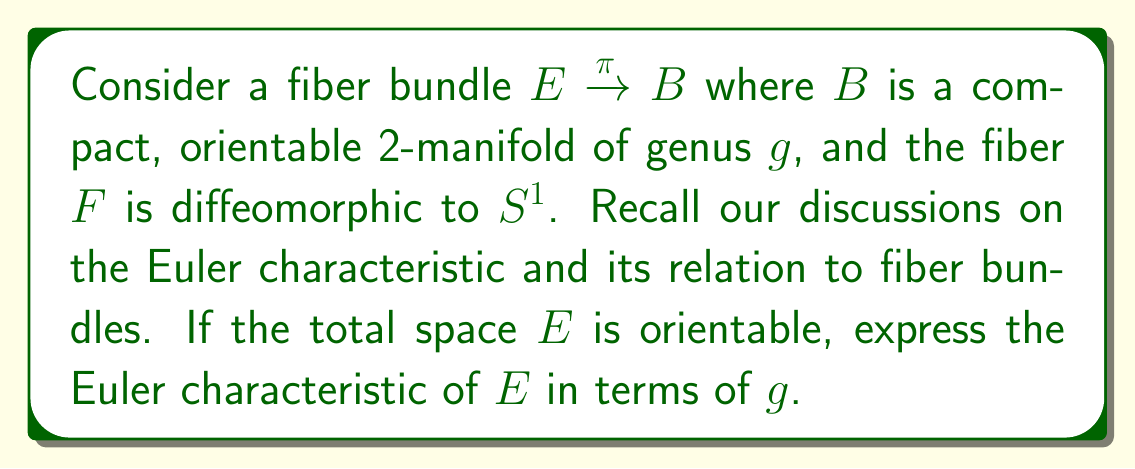Solve this math problem. Let's approach this step-by-step:

1) First, recall the multiplicativity property of the Euler characteristic for fiber bundles. For a fiber bundle $E \xrightarrow{\pi} B$ with fiber $F$, we have:

   $$\chi(E) = \chi(B) \cdot \chi(F)$$

2) Now, let's consider each component:

   a) For the base space $B$: 
      It's a compact, orientable 2-manifold of genus $g$. The Euler characteristic of such a surface is given by:
      $$\chi(B) = 2 - 2g$$

   b) For the fiber $F$:
      $F$ is diffeomorphic to $S^1$ (a circle). The Euler characteristic of a circle is:
      $$\chi(F) = 0$$

3) Substituting these into our multiplicativity formula:

   $$\chi(E) = (2 - 2g) \cdot 0 = 0$$

4) This result is independent of $g$, which might seem surprising at first. However, it makes sense topologically. The total space $E$ can be thought of as a "thickened" version of $B$, where each point is replaced by a circle. This process doesn't create or destroy any holes in a way that affects the Euler characteristic.

5) It's worth noting that this result holds true because the fiber is $S^1$. If the fiber were a different space with non-zero Euler characteristic, the result would depend on $g$.
Answer: The Euler characteristic of $E$ is 0, independent of the genus $g$ of the base space. 